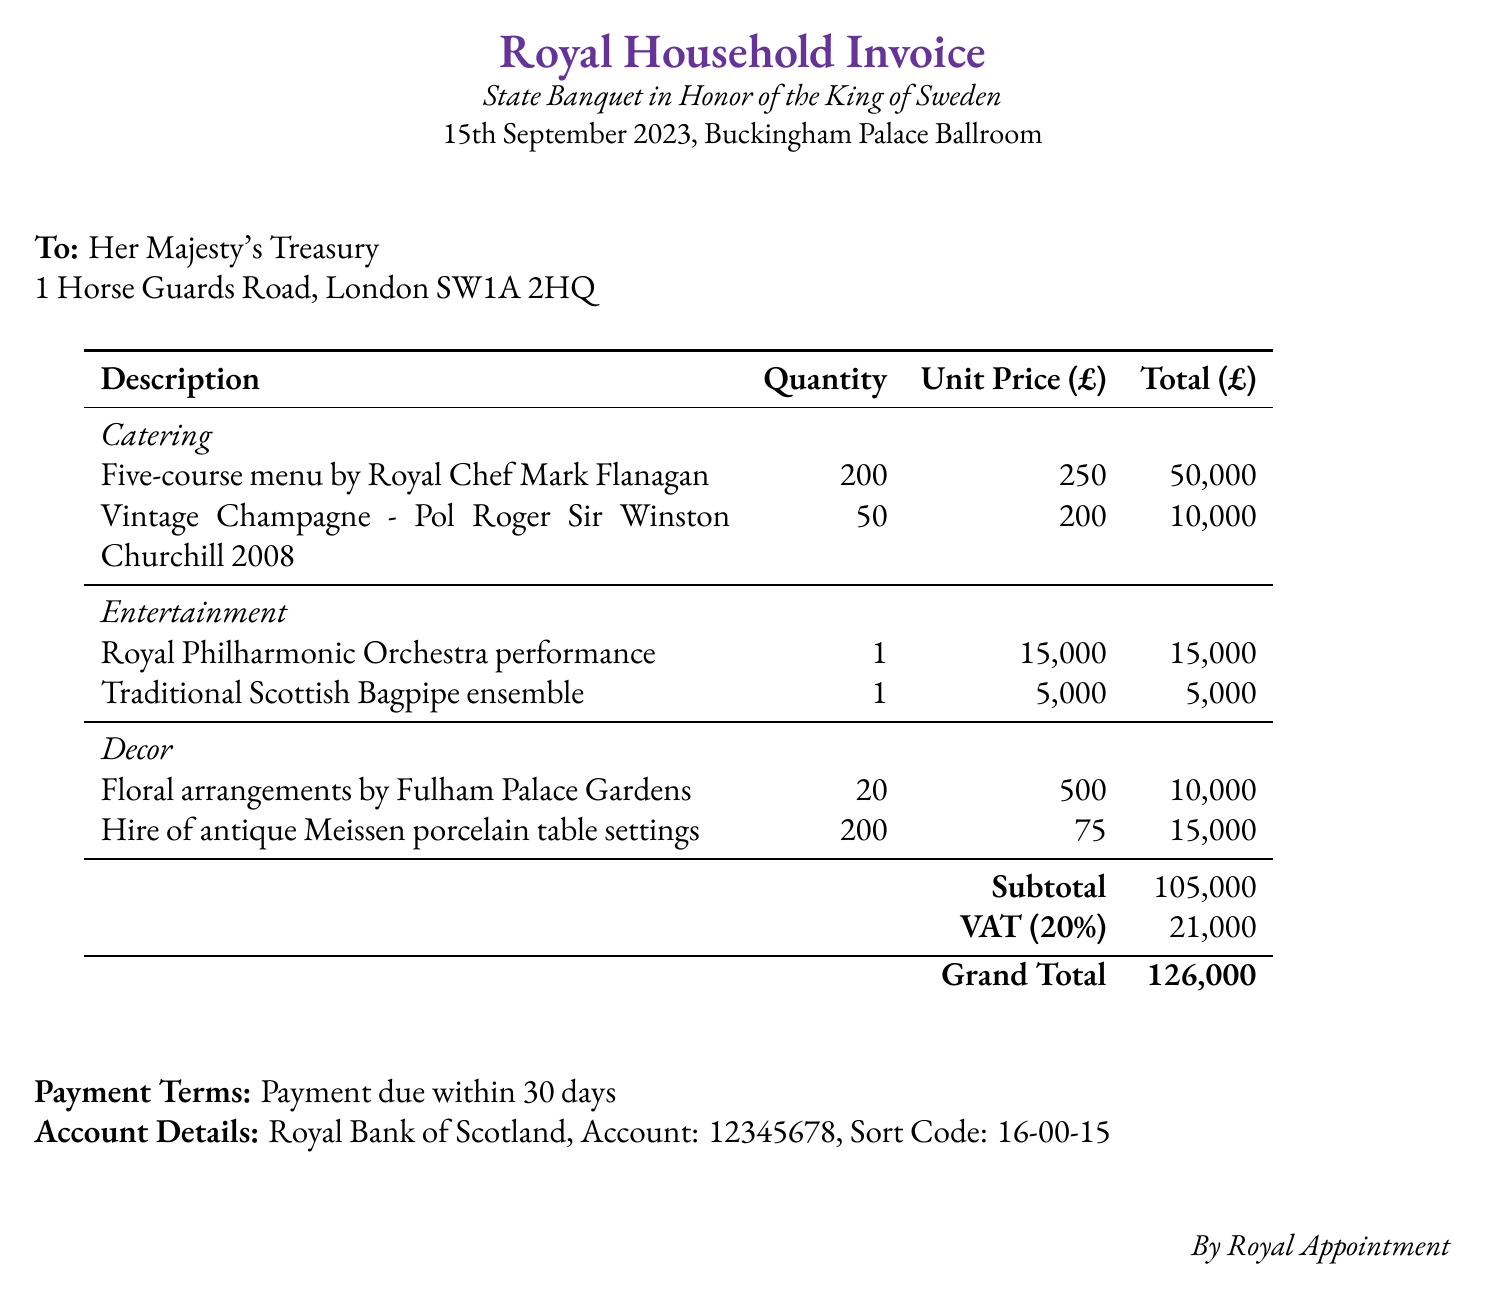What is the total cost for the catering? The catering total is calculated by adding the costs of the five-course menu and the vintage champagne, which are 50,000 and 10,000 respectively.
Answer: 60,000 What is the date of the state banquet? The date of the state banquet is explicitly stated at the beginning of the document.
Answer: 15th September 2023 How many guests are included in the invoice? The number of guests is specified in the catering section for the menu, which is 200.
Answer: 200 What is the total cost for entertainment? The total for entertainment includes the orchestra and bagpipe ensemble, calculated as 15,000 + 5,000.
Answer: 20,000 What is the VAT percentage applied? The VAT percentage is clearly mentioned in the document, indicating the rate charged on the subtotal.
Answer: 20% What is the grand total of the invoice? The grand total is provided at the bottom of the table, which includes all costs and VAT.
Answer: 126,000 Who provided the floral arrangements? The document states the source of floral arrangements, indicating the provider's name.
Answer: Fulham Palace Gardens What are the payment terms for this invoice? The payment terms are specified at the end of the document, detailing the due date for payment.
Answer: Payment due within 30 days How much was charged for the Royal Philharmonic Orchestra performance? The cost for the orchestra performance is listed under the entertainment section in the document.
Answer: 15,000 